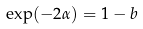<formula> <loc_0><loc_0><loc_500><loc_500>\exp ( - 2 \alpha ) = 1 - b</formula> 